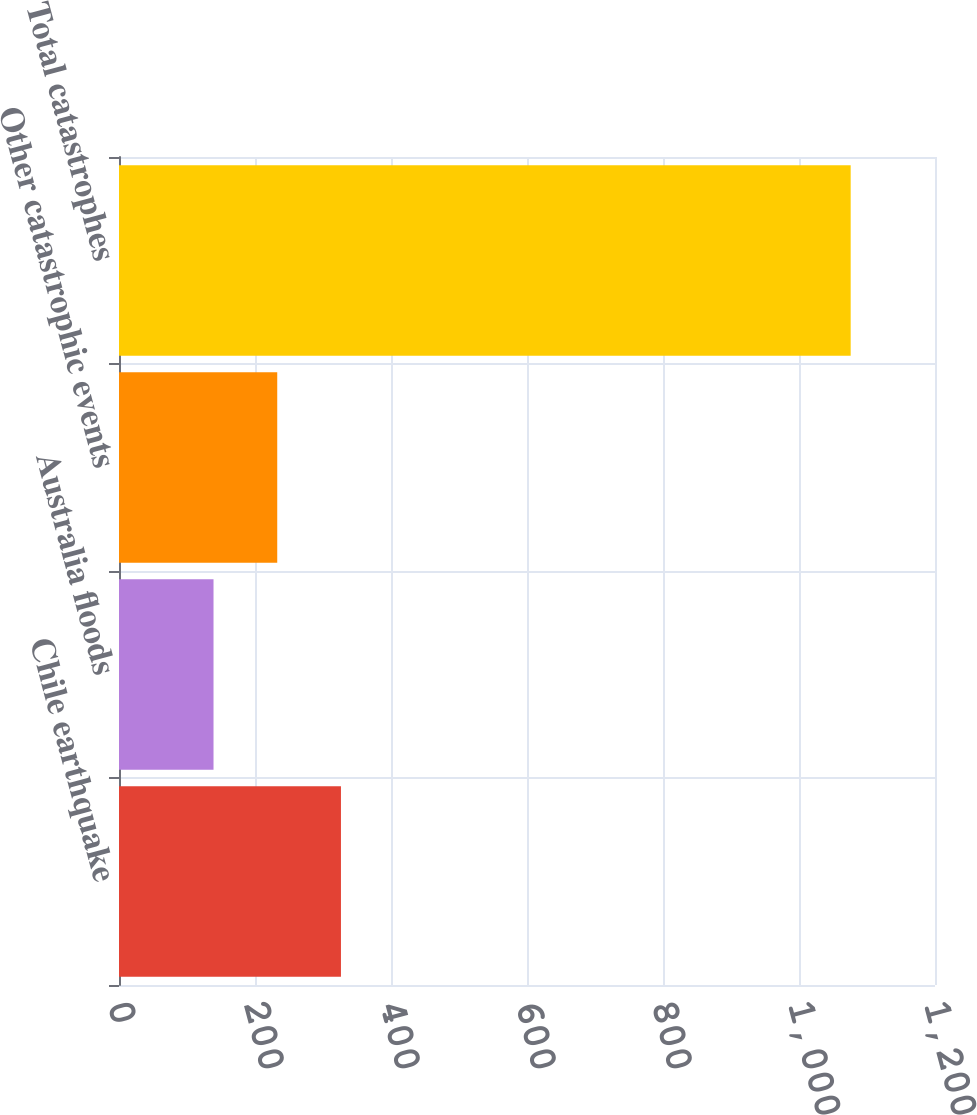<chart> <loc_0><loc_0><loc_500><loc_500><bar_chart><fcel>Chile earthquake<fcel>Australia floods<fcel>Other catastrophic events<fcel>Total catastrophes<nl><fcel>326.4<fcel>139<fcel>232.7<fcel>1076<nl></chart> 